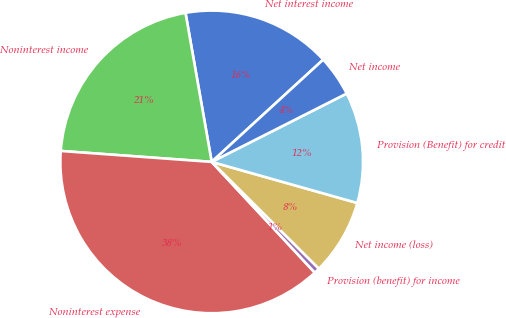Convert chart. <chart><loc_0><loc_0><loc_500><loc_500><pie_chart><fcel>Net interest income<fcel>Noninterest income<fcel>Noninterest expense<fcel>Provision (benefit) for income<fcel>Net income (loss)<fcel>Provision (Benefit) for credit<fcel>Net income<nl><fcel>15.96%<fcel>21.08%<fcel>38.09%<fcel>0.6%<fcel>8.09%<fcel>11.84%<fcel>4.35%<nl></chart> 